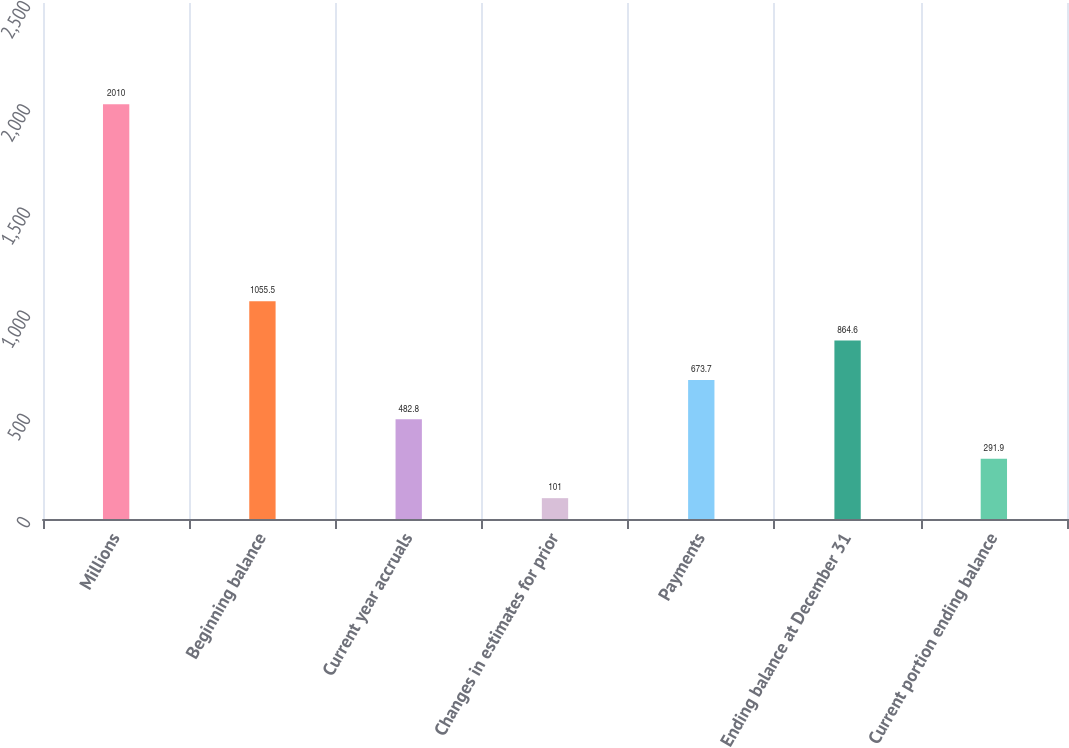Convert chart. <chart><loc_0><loc_0><loc_500><loc_500><bar_chart><fcel>Millions<fcel>Beginning balance<fcel>Current year accruals<fcel>Changes in estimates for prior<fcel>Payments<fcel>Ending balance at December 31<fcel>Current portion ending balance<nl><fcel>2010<fcel>1055.5<fcel>482.8<fcel>101<fcel>673.7<fcel>864.6<fcel>291.9<nl></chart> 